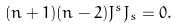Convert formula to latex. <formula><loc_0><loc_0><loc_500><loc_500>( n + 1 ) ( n - 2 ) J ^ { s } J _ { s } = 0 .</formula> 